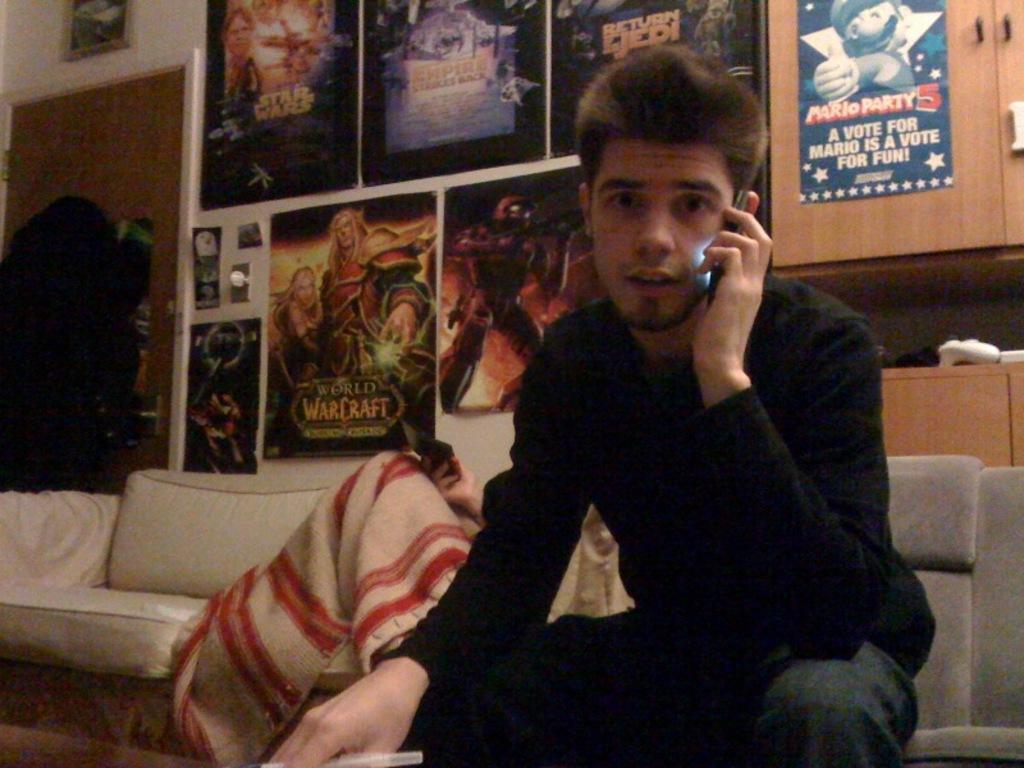Can you describe this image briefly? In the picture I can see a person wearing a black color dress is sitting on the sofa and talking on the mobile phone. In the background, we can see another person is covered with a blanket and holding a mobile phone and also sitting on the sofa. Here we can see many posters are posted to the wall, we can see wooden cupboards, some objects and the door on the left side of the image. 